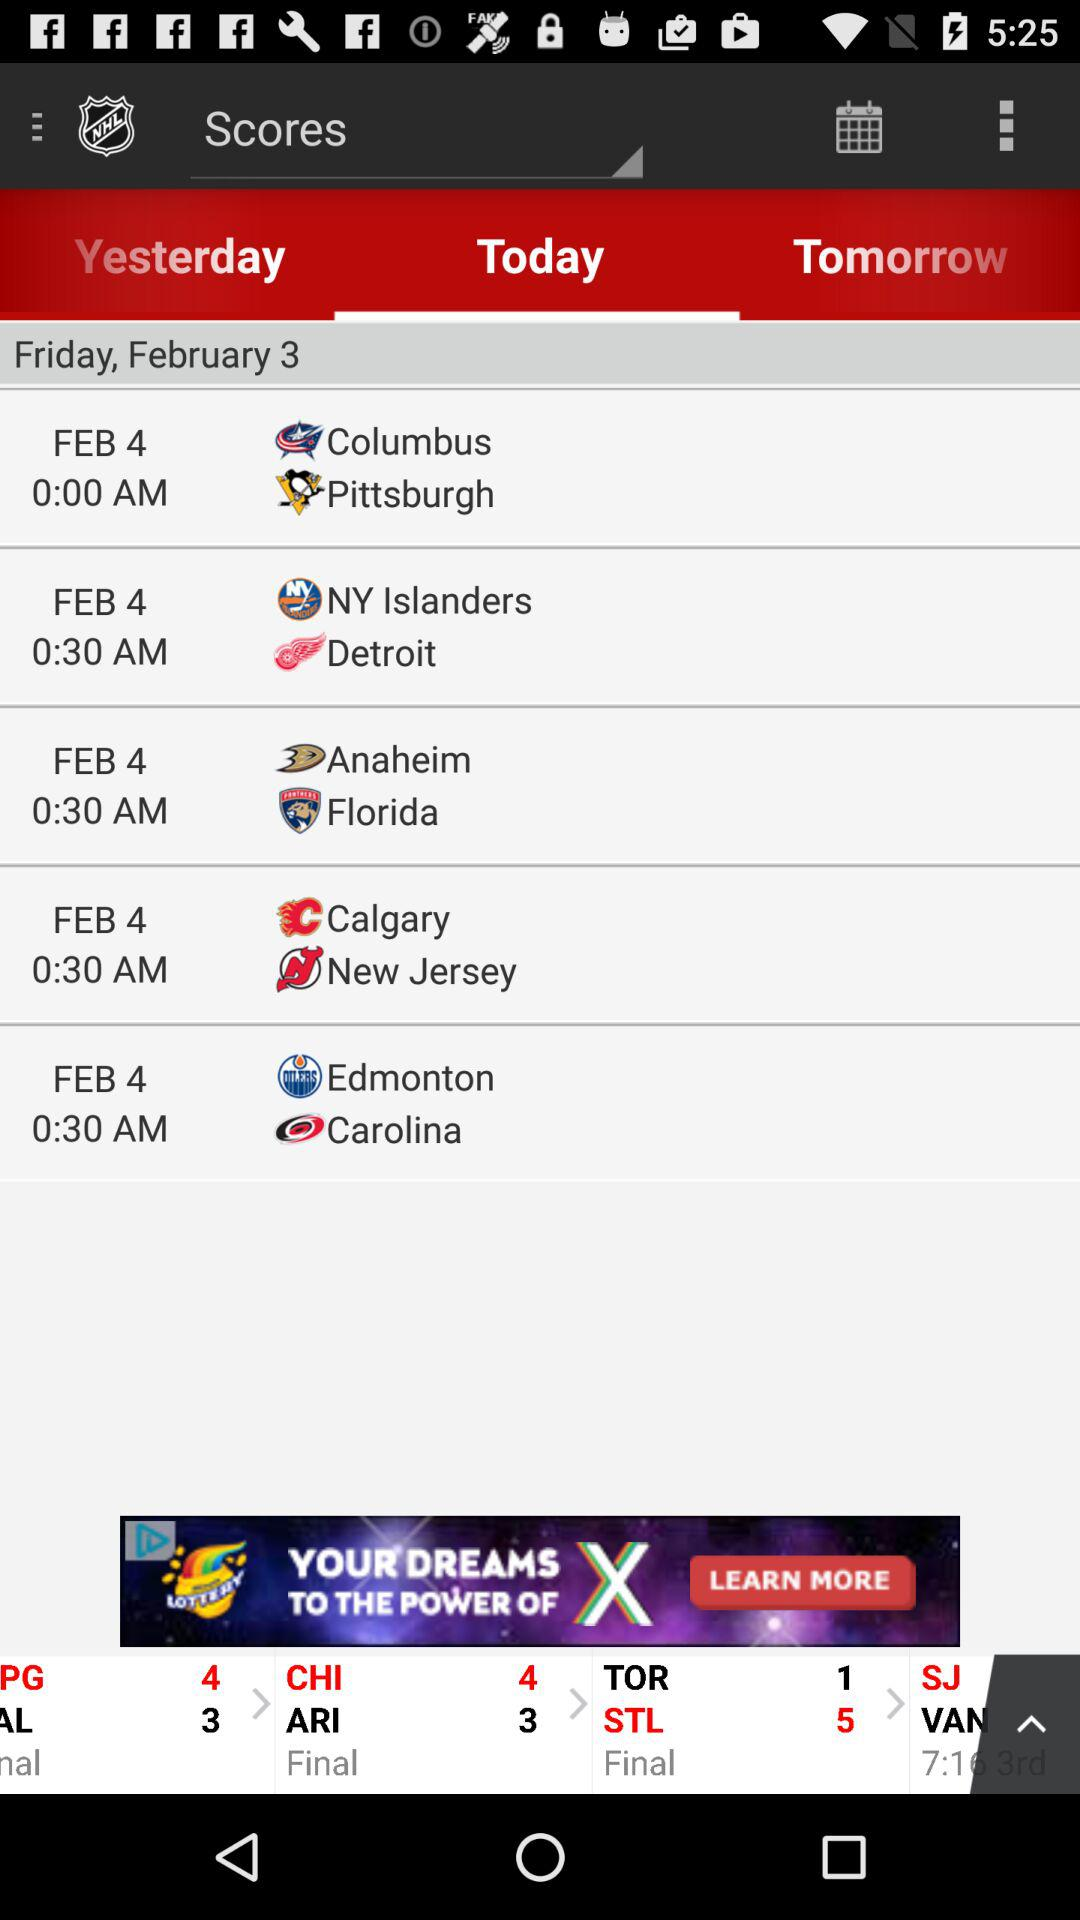Which tab is selected? The selected tab is "Today". 